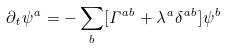<formula> <loc_0><loc_0><loc_500><loc_500>\partial _ { t } \psi ^ { a } = - \sum _ { b } [ \Gamma ^ { a b } + \lambda ^ { a } \delta ^ { a b } ] \psi ^ { b }</formula> 